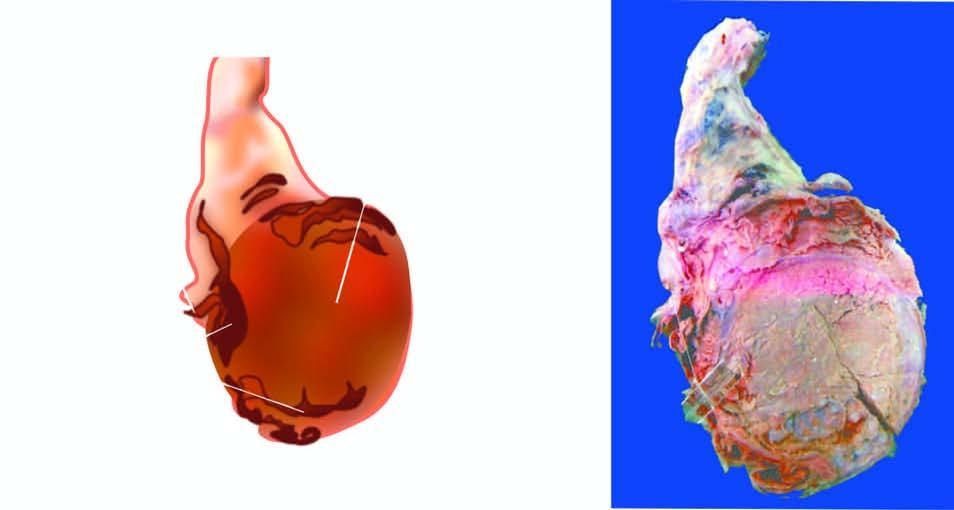what shows replacement of the entire testis by variegated mass having grey-white solid areas, cystic areas, honey-combed areas and foci of cartilage and bone?
Answer the question using a single word or phrase. Sectioned surface 